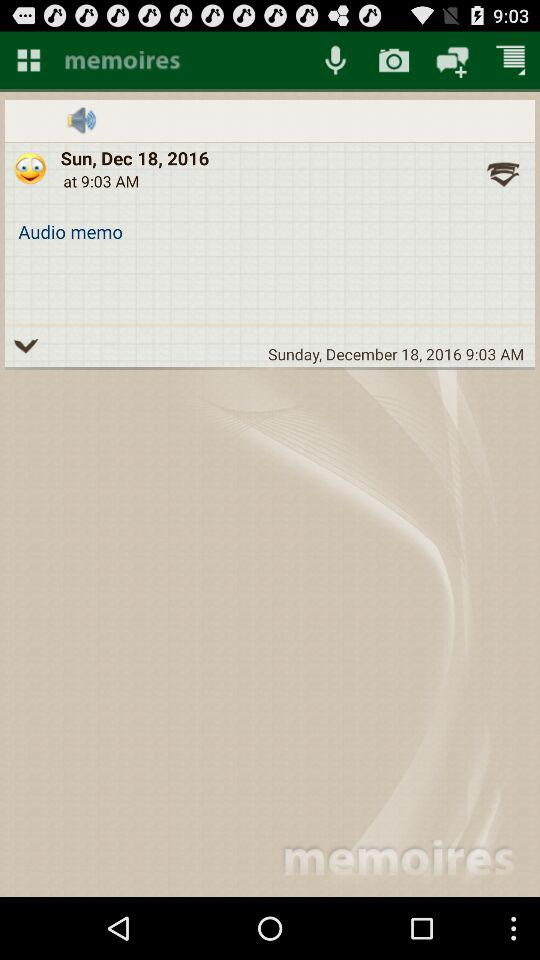What is the date given? The given date is Sunday, December 18, 2016. 